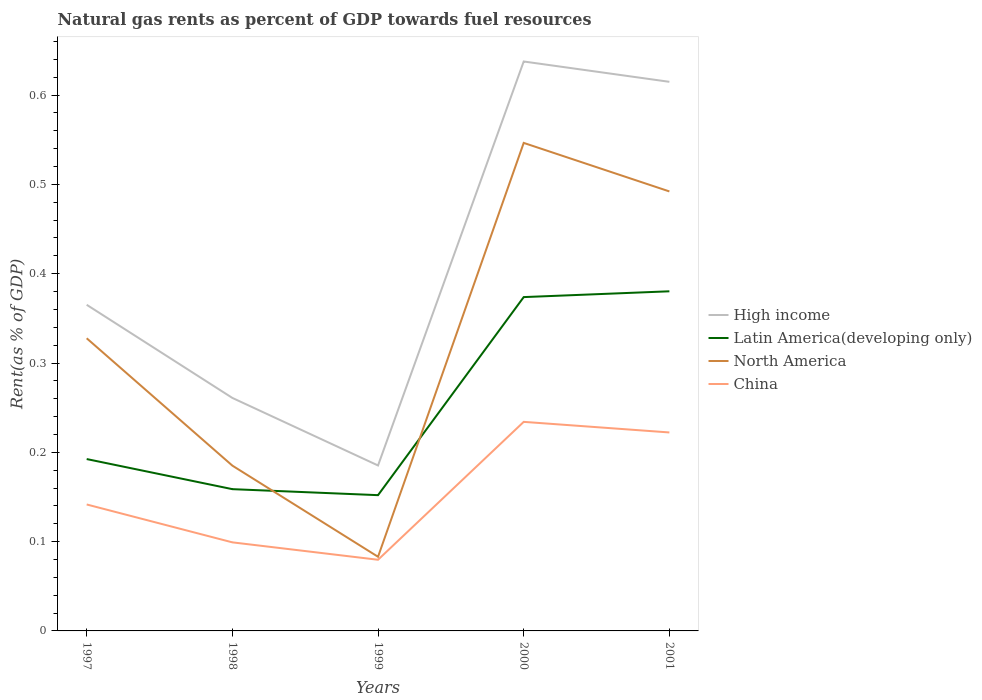How many different coloured lines are there?
Your response must be concise. 4. Does the line corresponding to North America intersect with the line corresponding to High income?
Keep it short and to the point. No. Across all years, what is the maximum matural gas rent in North America?
Offer a very short reply. 0.08. In which year was the matural gas rent in Latin America(developing only) maximum?
Provide a short and direct response. 1999. What is the total matural gas rent in China in the graph?
Keep it short and to the point. 0.01. What is the difference between the highest and the second highest matural gas rent in North America?
Your response must be concise. 0.46. What is the difference between the highest and the lowest matural gas rent in China?
Ensure brevity in your answer.  2. Is the matural gas rent in North America strictly greater than the matural gas rent in High income over the years?
Your response must be concise. Yes. Are the values on the major ticks of Y-axis written in scientific E-notation?
Your answer should be compact. No. Does the graph contain grids?
Make the answer very short. No. How are the legend labels stacked?
Provide a short and direct response. Vertical. What is the title of the graph?
Offer a very short reply. Natural gas rents as percent of GDP towards fuel resources. What is the label or title of the X-axis?
Give a very brief answer. Years. What is the label or title of the Y-axis?
Offer a very short reply. Rent(as % of GDP). What is the Rent(as % of GDP) in High income in 1997?
Your answer should be very brief. 0.37. What is the Rent(as % of GDP) of Latin America(developing only) in 1997?
Your answer should be very brief. 0.19. What is the Rent(as % of GDP) in North America in 1997?
Make the answer very short. 0.33. What is the Rent(as % of GDP) in China in 1997?
Your response must be concise. 0.14. What is the Rent(as % of GDP) in High income in 1998?
Ensure brevity in your answer.  0.26. What is the Rent(as % of GDP) in Latin America(developing only) in 1998?
Make the answer very short. 0.16. What is the Rent(as % of GDP) in North America in 1998?
Provide a succinct answer. 0.19. What is the Rent(as % of GDP) of China in 1998?
Offer a terse response. 0.1. What is the Rent(as % of GDP) in High income in 1999?
Make the answer very short. 0.19. What is the Rent(as % of GDP) in Latin America(developing only) in 1999?
Keep it short and to the point. 0.15. What is the Rent(as % of GDP) in North America in 1999?
Your answer should be very brief. 0.08. What is the Rent(as % of GDP) in China in 1999?
Keep it short and to the point. 0.08. What is the Rent(as % of GDP) in High income in 2000?
Make the answer very short. 0.64. What is the Rent(as % of GDP) of Latin America(developing only) in 2000?
Provide a short and direct response. 0.37. What is the Rent(as % of GDP) of North America in 2000?
Your answer should be compact. 0.55. What is the Rent(as % of GDP) in China in 2000?
Give a very brief answer. 0.23. What is the Rent(as % of GDP) in High income in 2001?
Make the answer very short. 0.61. What is the Rent(as % of GDP) in Latin America(developing only) in 2001?
Your response must be concise. 0.38. What is the Rent(as % of GDP) of North America in 2001?
Your answer should be very brief. 0.49. What is the Rent(as % of GDP) in China in 2001?
Offer a very short reply. 0.22. Across all years, what is the maximum Rent(as % of GDP) in High income?
Your response must be concise. 0.64. Across all years, what is the maximum Rent(as % of GDP) in Latin America(developing only)?
Offer a terse response. 0.38. Across all years, what is the maximum Rent(as % of GDP) of North America?
Provide a succinct answer. 0.55. Across all years, what is the maximum Rent(as % of GDP) in China?
Ensure brevity in your answer.  0.23. Across all years, what is the minimum Rent(as % of GDP) in High income?
Make the answer very short. 0.19. Across all years, what is the minimum Rent(as % of GDP) of Latin America(developing only)?
Your answer should be very brief. 0.15. Across all years, what is the minimum Rent(as % of GDP) of North America?
Your response must be concise. 0.08. Across all years, what is the minimum Rent(as % of GDP) of China?
Offer a very short reply. 0.08. What is the total Rent(as % of GDP) of High income in the graph?
Provide a succinct answer. 2.06. What is the total Rent(as % of GDP) of Latin America(developing only) in the graph?
Your response must be concise. 1.26. What is the total Rent(as % of GDP) of North America in the graph?
Give a very brief answer. 1.63. What is the total Rent(as % of GDP) in China in the graph?
Provide a succinct answer. 0.78. What is the difference between the Rent(as % of GDP) of High income in 1997 and that in 1998?
Your response must be concise. 0.1. What is the difference between the Rent(as % of GDP) in Latin America(developing only) in 1997 and that in 1998?
Make the answer very short. 0.03. What is the difference between the Rent(as % of GDP) in North America in 1997 and that in 1998?
Provide a succinct answer. 0.14. What is the difference between the Rent(as % of GDP) of China in 1997 and that in 1998?
Keep it short and to the point. 0.04. What is the difference between the Rent(as % of GDP) of High income in 1997 and that in 1999?
Ensure brevity in your answer.  0.18. What is the difference between the Rent(as % of GDP) in Latin America(developing only) in 1997 and that in 1999?
Give a very brief answer. 0.04. What is the difference between the Rent(as % of GDP) of North America in 1997 and that in 1999?
Provide a short and direct response. 0.24. What is the difference between the Rent(as % of GDP) in China in 1997 and that in 1999?
Give a very brief answer. 0.06. What is the difference between the Rent(as % of GDP) in High income in 1997 and that in 2000?
Give a very brief answer. -0.27. What is the difference between the Rent(as % of GDP) in Latin America(developing only) in 1997 and that in 2000?
Make the answer very short. -0.18. What is the difference between the Rent(as % of GDP) of North America in 1997 and that in 2000?
Keep it short and to the point. -0.22. What is the difference between the Rent(as % of GDP) of China in 1997 and that in 2000?
Keep it short and to the point. -0.09. What is the difference between the Rent(as % of GDP) in High income in 1997 and that in 2001?
Provide a short and direct response. -0.25. What is the difference between the Rent(as % of GDP) of Latin America(developing only) in 1997 and that in 2001?
Offer a terse response. -0.19. What is the difference between the Rent(as % of GDP) of North America in 1997 and that in 2001?
Offer a very short reply. -0.16. What is the difference between the Rent(as % of GDP) in China in 1997 and that in 2001?
Give a very brief answer. -0.08. What is the difference between the Rent(as % of GDP) in High income in 1998 and that in 1999?
Your response must be concise. 0.08. What is the difference between the Rent(as % of GDP) of Latin America(developing only) in 1998 and that in 1999?
Give a very brief answer. 0.01. What is the difference between the Rent(as % of GDP) in North America in 1998 and that in 1999?
Offer a very short reply. 0.1. What is the difference between the Rent(as % of GDP) of China in 1998 and that in 1999?
Provide a succinct answer. 0.02. What is the difference between the Rent(as % of GDP) of High income in 1998 and that in 2000?
Offer a terse response. -0.38. What is the difference between the Rent(as % of GDP) of Latin America(developing only) in 1998 and that in 2000?
Provide a succinct answer. -0.22. What is the difference between the Rent(as % of GDP) of North America in 1998 and that in 2000?
Provide a short and direct response. -0.36. What is the difference between the Rent(as % of GDP) of China in 1998 and that in 2000?
Provide a short and direct response. -0.13. What is the difference between the Rent(as % of GDP) of High income in 1998 and that in 2001?
Offer a very short reply. -0.35. What is the difference between the Rent(as % of GDP) in Latin America(developing only) in 1998 and that in 2001?
Your answer should be very brief. -0.22. What is the difference between the Rent(as % of GDP) in North America in 1998 and that in 2001?
Give a very brief answer. -0.31. What is the difference between the Rent(as % of GDP) of China in 1998 and that in 2001?
Make the answer very short. -0.12. What is the difference between the Rent(as % of GDP) of High income in 1999 and that in 2000?
Provide a succinct answer. -0.45. What is the difference between the Rent(as % of GDP) of Latin America(developing only) in 1999 and that in 2000?
Keep it short and to the point. -0.22. What is the difference between the Rent(as % of GDP) in North America in 1999 and that in 2000?
Offer a very short reply. -0.46. What is the difference between the Rent(as % of GDP) of China in 1999 and that in 2000?
Offer a terse response. -0.15. What is the difference between the Rent(as % of GDP) in High income in 1999 and that in 2001?
Give a very brief answer. -0.43. What is the difference between the Rent(as % of GDP) of Latin America(developing only) in 1999 and that in 2001?
Give a very brief answer. -0.23. What is the difference between the Rent(as % of GDP) in North America in 1999 and that in 2001?
Offer a very short reply. -0.41. What is the difference between the Rent(as % of GDP) in China in 1999 and that in 2001?
Provide a succinct answer. -0.14. What is the difference between the Rent(as % of GDP) of High income in 2000 and that in 2001?
Your answer should be compact. 0.02. What is the difference between the Rent(as % of GDP) of Latin America(developing only) in 2000 and that in 2001?
Provide a short and direct response. -0.01. What is the difference between the Rent(as % of GDP) of North America in 2000 and that in 2001?
Keep it short and to the point. 0.05. What is the difference between the Rent(as % of GDP) in China in 2000 and that in 2001?
Your answer should be compact. 0.01. What is the difference between the Rent(as % of GDP) of High income in 1997 and the Rent(as % of GDP) of Latin America(developing only) in 1998?
Offer a terse response. 0.21. What is the difference between the Rent(as % of GDP) of High income in 1997 and the Rent(as % of GDP) of North America in 1998?
Your response must be concise. 0.18. What is the difference between the Rent(as % of GDP) in High income in 1997 and the Rent(as % of GDP) in China in 1998?
Offer a very short reply. 0.27. What is the difference between the Rent(as % of GDP) in Latin America(developing only) in 1997 and the Rent(as % of GDP) in North America in 1998?
Offer a terse response. 0.01. What is the difference between the Rent(as % of GDP) in Latin America(developing only) in 1997 and the Rent(as % of GDP) in China in 1998?
Make the answer very short. 0.09. What is the difference between the Rent(as % of GDP) in North America in 1997 and the Rent(as % of GDP) in China in 1998?
Make the answer very short. 0.23. What is the difference between the Rent(as % of GDP) in High income in 1997 and the Rent(as % of GDP) in Latin America(developing only) in 1999?
Offer a terse response. 0.21. What is the difference between the Rent(as % of GDP) of High income in 1997 and the Rent(as % of GDP) of North America in 1999?
Provide a short and direct response. 0.28. What is the difference between the Rent(as % of GDP) of High income in 1997 and the Rent(as % of GDP) of China in 1999?
Your answer should be very brief. 0.29. What is the difference between the Rent(as % of GDP) of Latin America(developing only) in 1997 and the Rent(as % of GDP) of North America in 1999?
Your answer should be very brief. 0.11. What is the difference between the Rent(as % of GDP) in Latin America(developing only) in 1997 and the Rent(as % of GDP) in China in 1999?
Ensure brevity in your answer.  0.11. What is the difference between the Rent(as % of GDP) in North America in 1997 and the Rent(as % of GDP) in China in 1999?
Provide a short and direct response. 0.25. What is the difference between the Rent(as % of GDP) in High income in 1997 and the Rent(as % of GDP) in Latin America(developing only) in 2000?
Your answer should be very brief. -0.01. What is the difference between the Rent(as % of GDP) of High income in 1997 and the Rent(as % of GDP) of North America in 2000?
Your answer should be very brief. -0.18. What is the difference between the Rent(as % of GDP) of High income in 1997 and the Rent(as % of GDP) of China in 2000?
Give a very brief answer. 0.13. What is the difference between the Rent(as % of GDP) of Latin America(developing only) in 1997 and the Rent(as % of GDP) of North America in 2000?
Give a very brief answer. -0.35. What is the difference between the Rent(as % of GDP) in Latin America(developing only) in 1997 and the Rent(as % of GDP) in China in 2000?
Your answer should be very brief. -0.04. What is the difference between the Rent(as % of GDP) of North America in 1997 and the Rent(as % of GDP) of China in 2000?
Ensure brevity in your answer.  0.09. What is the difference between the Rent(as % of GDP) in High income in 1997 and the Rent(as % of GDP) in Latin America(developing only) in 2001?
Your answer should be compact. -0.02. What is the difference between the Rent(as % of GDP) in High income in 1997 and the Rent(as % of GDP) in North America in 2001?
Offer a terse response. -0.13. What is the difference between the Rent(as % of GDP) in High income in 1997 and the Rent(as % of GDP) in China in 2001?
Provide a short and direct response. 0.14. What is the difference between the Rent(as % of GDP) in Latin America(developing only) in 1997 and the Rent(as % of GDP) in North America in 2001?
Offer a very short reply. -0.3. What is the difference between the Rent(as % of GDP) of Latin America(developing only) in 1997 and the Rent(as % of GDP) of China in 2001?
Provide a short and direct response. -0.03. What is the difference between the Rent(as % of GDP) in North America in 1997 and the Rent(as % of GDP) in China in 2001?
Keep it short and to the point. 0.11. What is the difference between the Rent(as % of GDP) of High income in 1998 and the Rent(as % of GDP) of Latin America(developing only) in 1999?
Make the answer very short. 0.11. What is the difference between the Rent(as % of GDP) in High income in 1998 and the Rent(as % of GDP) in North America in 1999?
Provide a succinct answer. 0.18. What is the difference between the Rent(as % of GDP) in High income in 1998 and the Rent(as % of GDP) in China in 1999?
Your answer should be very brief. 0.18. What is the difference between the Rent(as % of GDP) in Latin America(developing only) in 1998 and the Rent(as % of GDP) in North America in 1999?
Make the answer very short. 0.08. What is the difference between the Rent(as % of GDP) of Latin America(developing only) in 1998 and the Rent(as % of GDP) of China in 1999?
Give a very brief answer. 0.08. What is the difference between the Rent(as % of GDP) in North America in 1998 and the Rent(as % of GDP) in China in 1999?
Ensure brevity in your answer.  0.11. What is the difference between the Rent(as % of GDP) of High income in 1998 and the Rent(as % of GDP) of Latin America(developing only) in 2000?
Your response must be concise. -0.11. What is the difference between the Rent(as % of GDP) in High income in 1998 and the Rent(as % of GDP) in North America in 2000?
Your answer should be compact. -0.29. What is the difference between the Rent(as % of GDP) of High income in 1998 and the Rent(as % of GDP) of China in 2000?
Make the answer very short. 0.03. What is the difference between the Rent(as % of GDP) in Latin America(developing only) in 1998 and the Rent(as % of GDP) in North America in 2000?
Make the answer very short. -0.39. What is the difference between the Rent(as % of GDP) in Latin America(developing only) in 1998 and the Rent(as % of GDP) in China in 2000?
Keep it short and to the point. -0.08. What is the difference between the Rent(as % of GDP) of North America in 1998 and the Rent(as % of GDP) of China in 2000?
Your response must be concise. -0.05. What is the difference between the Rent(as % of GDP) of High income in 1998 and the Rent(as % of GDP) of Latin America(developing only) in 2001?
Your answer should be very brief. -0.12. What is the difference between the Rent(as % of GDP) in High income in 1998 and the Rent(as % of GDP) in North America in 2001?
Make the answer very short. -0.23. What is the difference between the Rent(as % of GDP) in High income in 1998 and the Rent(as % of GDP) in China in 2001?
Your answer should be very brief. 0.04. What is the difference between the Rent(as % of GDP) of Latin America(developing only) in 1998 and the Rent(as % of GDP) of North America in 2001?
Provide a succinct answer. -0.33. What is the difference between the Rent(as % of GDP) in Latin America(developing only) in 1998 and the Rent(as % of GDP) in China in 2001?
Keep it short and to the point. -0.06. What is the difference between the Rent(as % of GDP) of North America in 1998 and the Rent(as % of GDP) of China in 2001?
Your answer should be compact. -0.04. What is the difference between the Rent(as % of GDP) of High income in 1999 and the Rent(as % of GDP) of Latin America(developing only) in 2000?
Ensure brevity in your answer.  -0.19. What is the difference between the Rent(as % of GDP) of High income in 1999 and the Rent(as % of GDP) of North America in 2000?
Ensure brevity in your answer.  -0.36. What is the difference between the Rent(as % of GDP) in High income in 1999 and the Rent(as % of GDP) in China in 2000?
Your answer should be very brief. -0.05. What is the difference between the Rent(as % of GDP) in Latin America(developing only) in 1999 and the Rent(as % of GDP) in North America in 2000?
Your answer should be compact. -0.39. What is the difference between the Rent(as % of GDP) in Latin America(developing only) in 1999 and the Rent(as % of GDP) in China in 2000?
Offer a very short reply. -0.08. What is the difference between the Rent(as % of GDP) of North America in 1999 and the Rent(as % of GDP) of China in 2000?
Your response must be concise. -0.15. What is the difference between the Rent(as % of GDP) of High income in 1999 and the Rent(as % of GDP) of Latin America(developing only) in 2001?
Provide a succinct answer. -0.2. What is the difference between the Rent(as % of GDP) of High income in 1999 and the Rent(as % of GDP) of North America in 2001?
Keep it short and to the point. -0.31. What is the difference between the Rent(as % of GDP) in High income in 1999 and the Rent(as % of GDP) in China in 2001?
Your response must be concise. -0.04. What is the difference between the Rent(as % of GDP) in Latin America(developing only) in 1999 and the Rent(as % of GDP) in North America in 2001?
Your answer should be very brief. -0.34. What is the difference between the Rent(as % of GDP) in Latin America(developing only) in 1999 and the Rent(as % of GDP) in China in 2001?
Offer a very short reply. -0.07. What is the difference between the Rent(as % of GDP) of North America in 1999 and the Rent(as % of GDP) of China in 2001?
Keep it short and to the point. -0.14. What is the difference between the Rent(as % of GDP) of High income in 2000 and the Rent(as % of GDP) of Latin America(developing only) in 2001?
Provide a succinct answer. 0.26. What is the difference between the Rent(as % of GDP) of High income in 2000 and the Rent(as % of GDP) of North America in 2001?
Make the answer very short. 0.15. What is the difference between the Rent(as % of GDP) in High income in 2000 and the Rent(as % of GDP) in China in 2001?
Your response must be concise. 0.42. What is the difference between the Rent(as % of GDP) of Latin America(developing only) in 2000 and the Rent(as % of GDP) of North America in 2001?
Your answer should be compact. -0.12. What is the difference between the Rent(as % of GDP) of Latin America(developing only) in 2000 and the Rent(as % of GDP) of China in 2001?
Keep it short and to the point. 0.15. What is the difference between the Rent(as % of GDP) in North America in 2000 and the Rent(as % of GDP) in China in 2001?
Your answer should be very brief. 0.32. What is the average Rent(as % of GDP) in High income per year?
Give a very brief answer. 0.41. What is the average Rent(as % of GDP) in Latin America(developing only) per year?
Offer a terse response. 0.25. What is the average Rent(as % of GDP) in North America per year?
Your response must be concise. 0.33. What is the average Rent(as % of GDP) of China per year?
Provide a succinct answer. 0.16. In the year 1997, what is the difference between the Rent(as % of GDP) in High income and Rent(as % of GDP) in Latin America(developing only)?
Keep it short and to the point. 0.17. In the year 1997, what is the difference between the Rent(as % of GDP) in High income and Rent(as % of GDP) in North America?
Provide a succinct answer. 0.04. In the year 1997, what is the difference between the Rent(as % of GDP) in High income and Rent(as % of GDP) in China?
Give a very brief answer. 0.22. In the year 1997, what is the difference between the Rent(as % of GDP) in Latin America(developing only) and Rent(as % of GDP) in North America?
Provide a short and direct response. -0.14. In the year 1997, what is the difference between the Rent(as % of GDP) of Latin America(developing only) and Rent(as % of GDP) of China?
Give a very brief answer. 0.05. In the year 1997, what is the difference between the Rent(as % of GDP) in North America and Rent(as % of GDP) in China?
Your answer should be compact. 0.19. In the year 1998, what is the difference between the Rent(as % of GDP) in High income and Rent(as % of GDP) in Latin America(developing only)?
Your response must be concise. 0.1. In the year 1998, what is the difference between the Rent(as % of GDP) in High income and Rent(as % of GDP) in North America?
Make the answer very short. 0.08. In the year 1998, what is the difference between the Rent(as % of GDP) in High income and Rent(as % of GDP) in China?
Ensure brevity in your answer.  0.16. In the year 1998, what is the difference between the Rent(as % of GDP) of Latin America(developing only) and Rent(as % of GDP) of North America?
Ensure brevity in your answer.  -0.03. In the year 1998, what is the difference between the Rent(as % of GDP) of Latin America(developing only) and Rent(as % of GDP) of China?
Make the answer very short. 0.06. In the year 1998, what is the difference between the Rent(as % of GDP) in North America and Rent(as % of GDP) in China?
Keep it short and to the point. 0.09. In the year 1999, what is the difference between the Rent(as % of GDP) of High income and Rent(as % of GDP) of Latin America(developing only)?
Make the answer very short. 0.03. In the year 1999, what is the difference between the Rent(as % of GDP) in High income and Rent(as % of GDP) in North America?
Ensure brevity in your answer.  0.1. In the year 1999, what is the difference between the Rent(as % of GDP) in High income and Rent(as % of GDP) in China?
Keep it short and to the point. 0.11. In the year 1999, what is the difference between the Rent(as % of GDP) in Latin America(developing only) and Rent(as % of GDP) in North America?
Keep it short and to the point. 0.07. In the year 1999, what is the difference between the Rent(as % of GDP) of Latin America(developing only) and Rent(as % of GDP) of China?
Your response must be concise. 0.07. In the year 1999, what is the difference between the Rent(as % of GDP) of North America and Rent(as % of GDP) of China?
Keep it short and to the point. 0. In the year 2000, what is the difference between the Rent(as % of GDP) of High income and Rent(as % of GDP) of Latin America(developing only)?
Offer a very short reply. 0.26. In the year 2000, what is the difference between the Rent(as % of GDP) in High income and Rent(as % of GDP) in North America?
Ensure brevity in your answer.  0.09. In the year 2000, what is the difference between the Rent(as % of GDP) of High income and Rent(as % of GDP) of China?
Give a very brief answer. 0.4. In the year 2000, what is the difference between the Rent(as % of GDP) of Latin America(developing only) and Rent(as % of GDP) of North America?
Your answer should be compact. -0.17. In the year 2000, what is the difference between the Rent(as % of GDP) in Latin America(developing only) and Rent(as % of GDP) in China?
Keep it short and to the point. 0.14. In the year 2000, what is the difference between the Rent(as % of GDP) of North America and Rent(as % of GDP) of China?
Provide a short and direct response. 0.31. In the year 2001, what is the difference between the Rent(as % of GDP) in High income and Rent(as % of GDP) in Latin America(developing only)?
Your answer should be very brief. 0.23. In the year 2001, what is the difference between the Rent(as % of GDP) in High income and Rent(as % of GDP) in North America?
Your answer should be very brief. 0.12. In the year 2001, what is the difference between the Rent(as % of GDP) in High income and Rent(as % of GDP) in China?
Provide a short and direct response. 0.39. In the year 2001, what is the difference between the Rent(as % of GDP) of Latin America(developing only) and Rent(as % of GDP) of North America?
Give a very brief answer. -0.11. In the year 2001, what is the difference between the Rent(as % of GDP) of Latin America(developing only) and Rent(as % of GDP) of China?
Offer a very short reply. 0.16. In the year 2001, what is the difference between the Rent(as % of GDP) of North America and Rent(as % of GDP) of China?
Ensure brevity in your answer.  0.27. What is the ratio of the Rent(as % of GDP) in High income in 1997 to that in 1998?
Your response must be concise. 1.4. What is the ratio of the Rent(as % of GDP) in Latin America(developing only) in 1997 to that in 1998?
Make the answer very short. 1.21. What is the ratio of the Rent(as % of GDP) in North America in 1997 to that in 1998?
Your answer should be compact. 1.77. What is the ratio of the Rent(as % of GDP) in China in 1997 to that in 1998?
Your response must be concise. 1.43. What is the ratio of the Rent(as % of GDP) of High income in 1997 to that in 1999?
Provide a short and direct response. 1.97. What is the ratio of the Rent(as % of GDP) of Latin America(developing only) in 1997 to that in 1999?
Your answer should be compact. 1.27. What is the ratio of the Rent(as % of GDP) in North America in 1997 to that in 1999?
Offer a very short reply. 3.95. What is the ratio of the Rent(as % of GDP) of China in 1997 to that in 1999?
Your response must be concise. 1.78. What is the ratio of the Rent(as % of GDP) in High income in 1997 to that in 2000?
Your response must be concise. 0.57. What is the ratio of the Rent(as % of GDP) of Latin America(developing only) in 1997 to that in 2000?
Ensure brevity in your answer.  0.51. What is the ratio of the Rent(as % of GDP) in North America in 1997 to that in 2000?
Offer a very short reply. 0.6. What is the ratio of the Rent(as % of GDP) in China in 1997 to that in 2000?
Keep it short and to the point. 0.6. What is the ratio of the Rent(as % of GDP) of High income in 1997 to that in 2001?
Keep it short and to the point. 0.59. What is the ratio of the Rent(as % of GDP) in Latin America(developing only) in 1997 to that in 2001?
Provide a short and direct response. 0.51. What is the ratio of the Rent(as % of GDP) of North America in 1997 to that in 2001?
Make the answer very short. 0.67. What is the ratio of the Rent(as % of GDP) in China in 1997 to that in 2001?
Offer a very short reply. 0.64. What is the ratio of the Rent(as % of GDP) in High income in 1998 to that in 1999?
Give a very brief answer. 1.41. What is the ratio of the Rent(as % of GDP) in Latin America(developing only) in 1998 to that in 1999?
Provide a succinct answer. 1.04. What is the ratio of the Rent(as % of GDP) in North America in 1998 to that in 1999?
Provide a short and direct response. 2.23. What is the ratio of the Rent(as % of GDP) in China in 1998 to that in 1999?
Make the answer very short. 1.24. What is the ratio of the Rent(as % of GDP) in High income in 1998 to that in 2000?
Offer a very short reply. 0.41. What is the ratio of the Rent(as % of GDP) in Latin America(developing only) in 1998 to that in 2000?
Provide a short and direct response. 0.42. What is the ratio of the Rent(as % of GDP) of North America in 1998 to that in 2000?
Offer a terse response. 0.34. What is the ratio of the Rent(as % of GDP) of China in 1998 to that in 2000?
Offer a terse response. 0.42. What is the ratio of the Rent(as % of GDP) in High income in 1998 to that in 2001?
Give a very brief answer. 0.42. What is the ratio of the Rent(as % of GDP) in Latin America(developing only) in 1998 to that in 2001?
Offer a very short reply. 0.42. What is the ratio of the Rent(as % of GDP) of North America in 1998 to that in 2001?
Your answer should be very brief. 0.38. What is the ratio of the Rent(as % of GDP) in China in 1998 to that in 2001?
Your answer should be very brief. 0.45. What is the ratio of the Rent(as % of GDP) in High income in 1999 to that in 2000?
Keep it short and to the point. 0.29. What is the ratio of the Rent(as % of GDP) in Latin America(developing only) in 1999 to that in 2000?
Keep it short and to the point. 0.41. What is the ratio of the Rent(as % of GDP) in North America in 1999 to that in 2000?
Keep it short and to the point. 0.15. What is the ratio of the Rent(as % of GDP) in China in 1999 to that in 2000?
Offer a terse response. 0.34. What is the ratio of the Rent(as % of GDP) of High income in 1999 to that in 2001?
Keep it short and to the point. 0.3. What is the ratio of the Rent(as % of GDP) of Latin America(developing only) in 1999 to that in 2001?
Ensure brevity in your answer.  0.4. What is the ratio of the Rent(as % of GDP) in North America in 1999 to that in 2001?
Your response must be concise. 0.17. What is the ratio of the Rent(as % of GDP) of China in 1999 to that in 2001?
Keep it short and to the point. 0.36. What is the ratio of the Rent(as % of GDP) of Latin America(developing only) in 2000 to that in 2001?
Your answer should be very brief. 0.98. What is the ratio of the Rent(as % of GDP) in North America in 2000 to that in 2001?
Your response must be concise. 1.11. What is the ratio of the Rent(as % of GDP) of China in 2000 to that in 2001?
Provide a short and direct response. 1.05. What is the difference between the highest and the second highest Rent(as % of GDP) in High income?
Make the answer very short. 0.02. What is the difference between the highest and the second highest Rent(as % of GDP) of Latin America(developing only)?
Your answer should be very brief. 0.01. What is the difference between the highest and the second highest Rent(as % of GDP) of North America?
Keep it short and to the point. 0.05. What is the difference between the highest and the second highest Rent(as % of GDP) of China?
Ensure brevity in your answer.  0.01. What is the difference between the highest and the lowest Rent(as % of GDP) of High income?
Provide a succinct answer. 0.45. What is the difference between the highest and the lowest Rent(as % of GDP) in Latin America(developing only)?
Make the answer very short. 0.23. What is the difference between the highest and the lowest Rent(as % of GDP) in North America?
Offer a very short reply. 0.46. What is the difference between the highest and the lowest Rent(as % of GDP) of China?
Give a very brief answer. 0.15. 